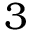Convert formula to latex. <formula><loc_0><loc_0><loc_500><loc_500>3</formula> 